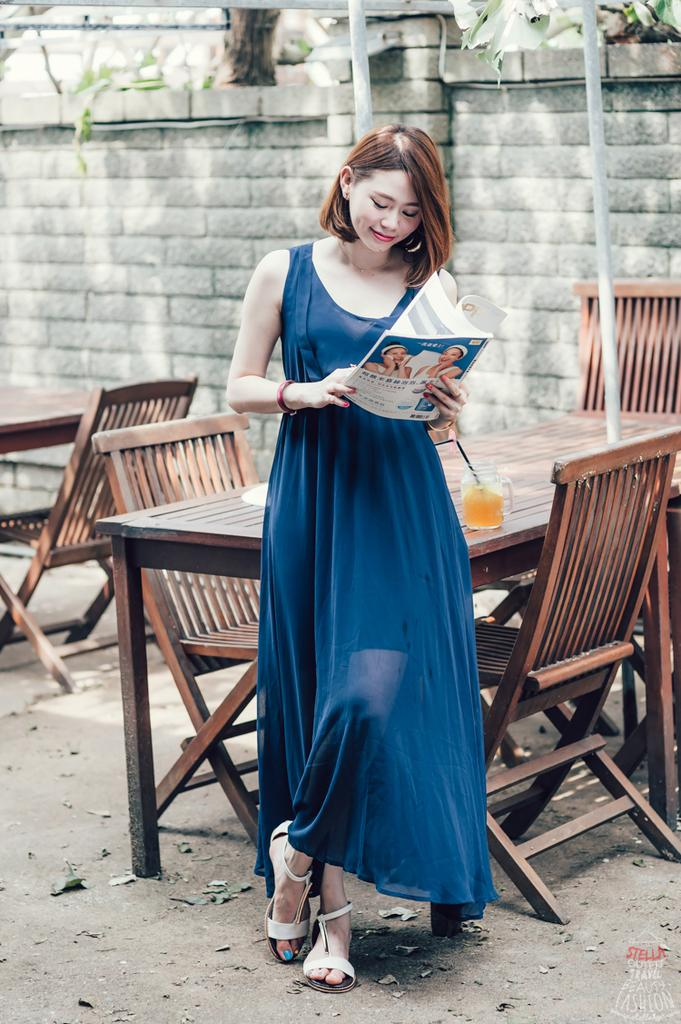What is the main subject of the image? There is a woman in the image. Can you describe what the woman is wearing? The woman is wearing a blue gown. What is the woman holding in the image? The woman is holding a book. What furniture is present in the image? There is a table and chairs beside the table in the image. What is on the table? There is a glass with juice and a straw on the table. What can be seen in the background of the image? There is a brick wall in the background of the image. What type of industry can be seen in the background of the image? There is no industry present in the image; it features a brick wall in the background. How many rays of sunlight are visible in the image? There is no mention of sunlight or rays in the image; it is focused on the woman, her clothing, and the surrounding environment. 